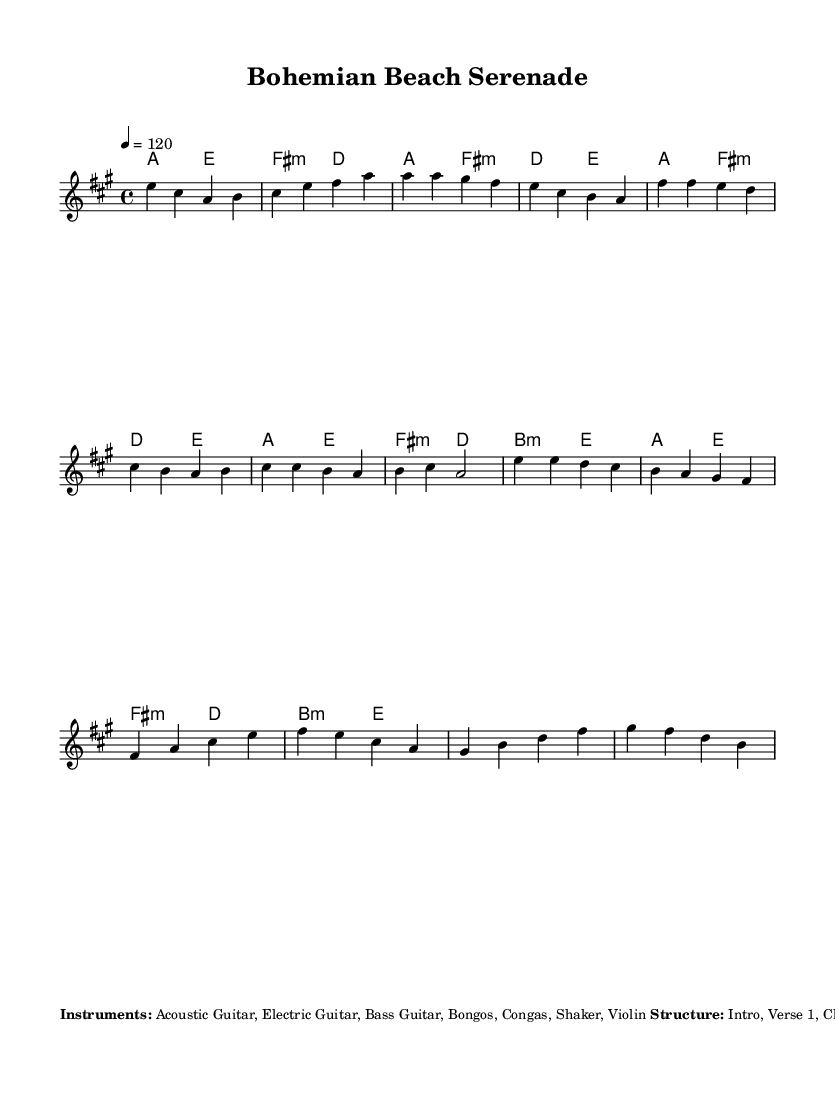What is the key signature of this music? The key signature is indicated at the beginning of the music, showing that there are three sharps. This corresponds to the key of A major.
Answer: A major What is the time signature of the piece? The time signature is shown in the beginning, represented as 4/4, which means there are four beats in each measure, and the quarter note gets the beat.
Answer: 4/4 What is the tempo marking for this piece? The tempo marking is noted at the beginning with "4 = 120", indicating a tempo of 120 beats per minute.
Answer: 120 How many main sections does the music have? By analyzing the structure listed in the markup, it indicates that there are eight distinct sections labeled: Intro, Verse 1, Chorus, Verse 2, Chorus, Bridge, Chorus, and Outro.
Answer: Eight sections What is the rhythm pattern for the acoustic guitar? The rhythm pattern for the acoustic guitar is described in the markup as: D DU UDU, which represents a specific strumming pattern used throughout the piece.
Answer: D DU UDU What instruments are used in this music? The markup lists the instruments involved in the composition. These are Acoustic Guitar, Electric Guitar, Bass Guitar, Bongos, Congas, Shaker, and Violin.
Answer: Acoustic Guitar, Electric Guitar, Bass Guitar, Bongos, Congas, Shaker, Violin What effect should be used on the electric guitar for ambience? The additional notes section of the markup mentions using reverb and delay effects on the electric guitar to create a dreamy atmosphere.
Answer: Reverb and delay 